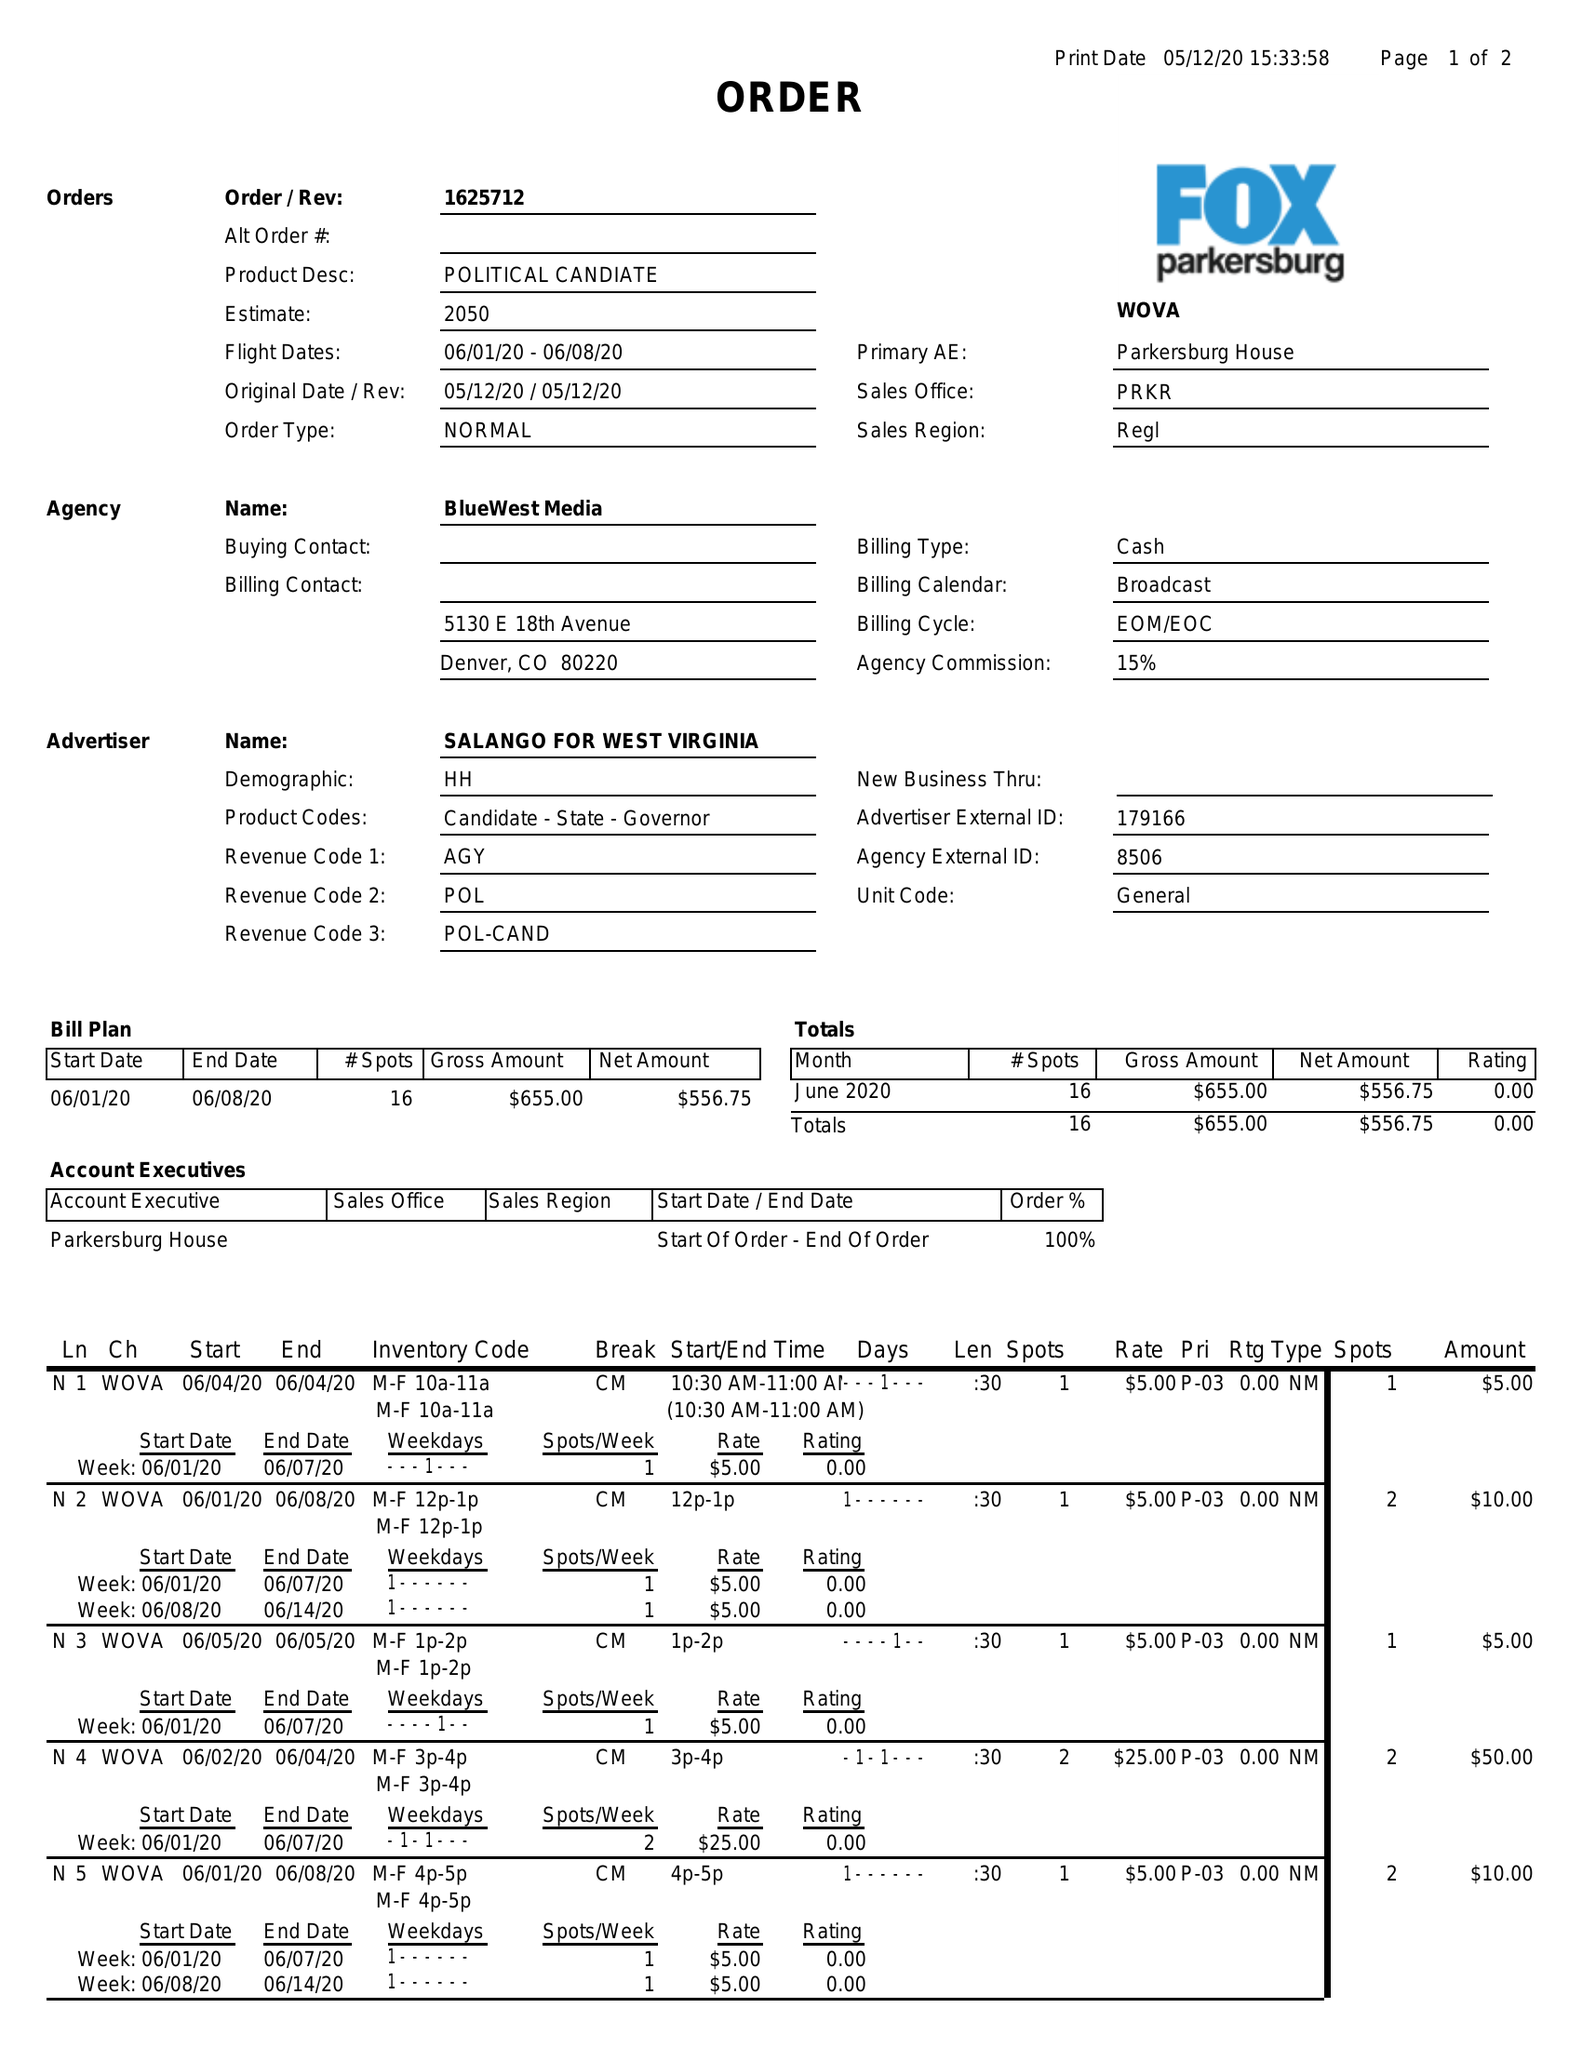What is the value for the advertiser?
Answer the question using a single word or phrase. SALANGO FOR WEST VIRGINIA 